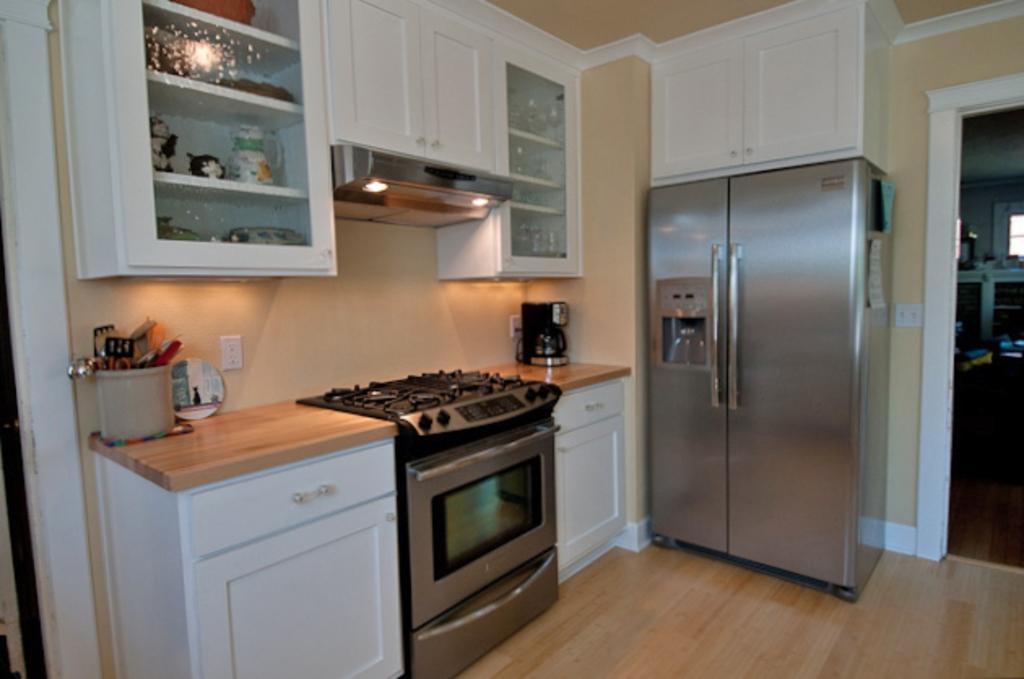How would you summarize this image in a sentence or two? In this picture we can see a kitchen room, on the left side we can see stove, an oven, coffee machine, cupboards and a bucket, there is a refrigerator in the middle, we can see shelves on the left side there are some glasses on these shelves, on the right side there is another room, we can see a paper pasted on the refrigerator. 